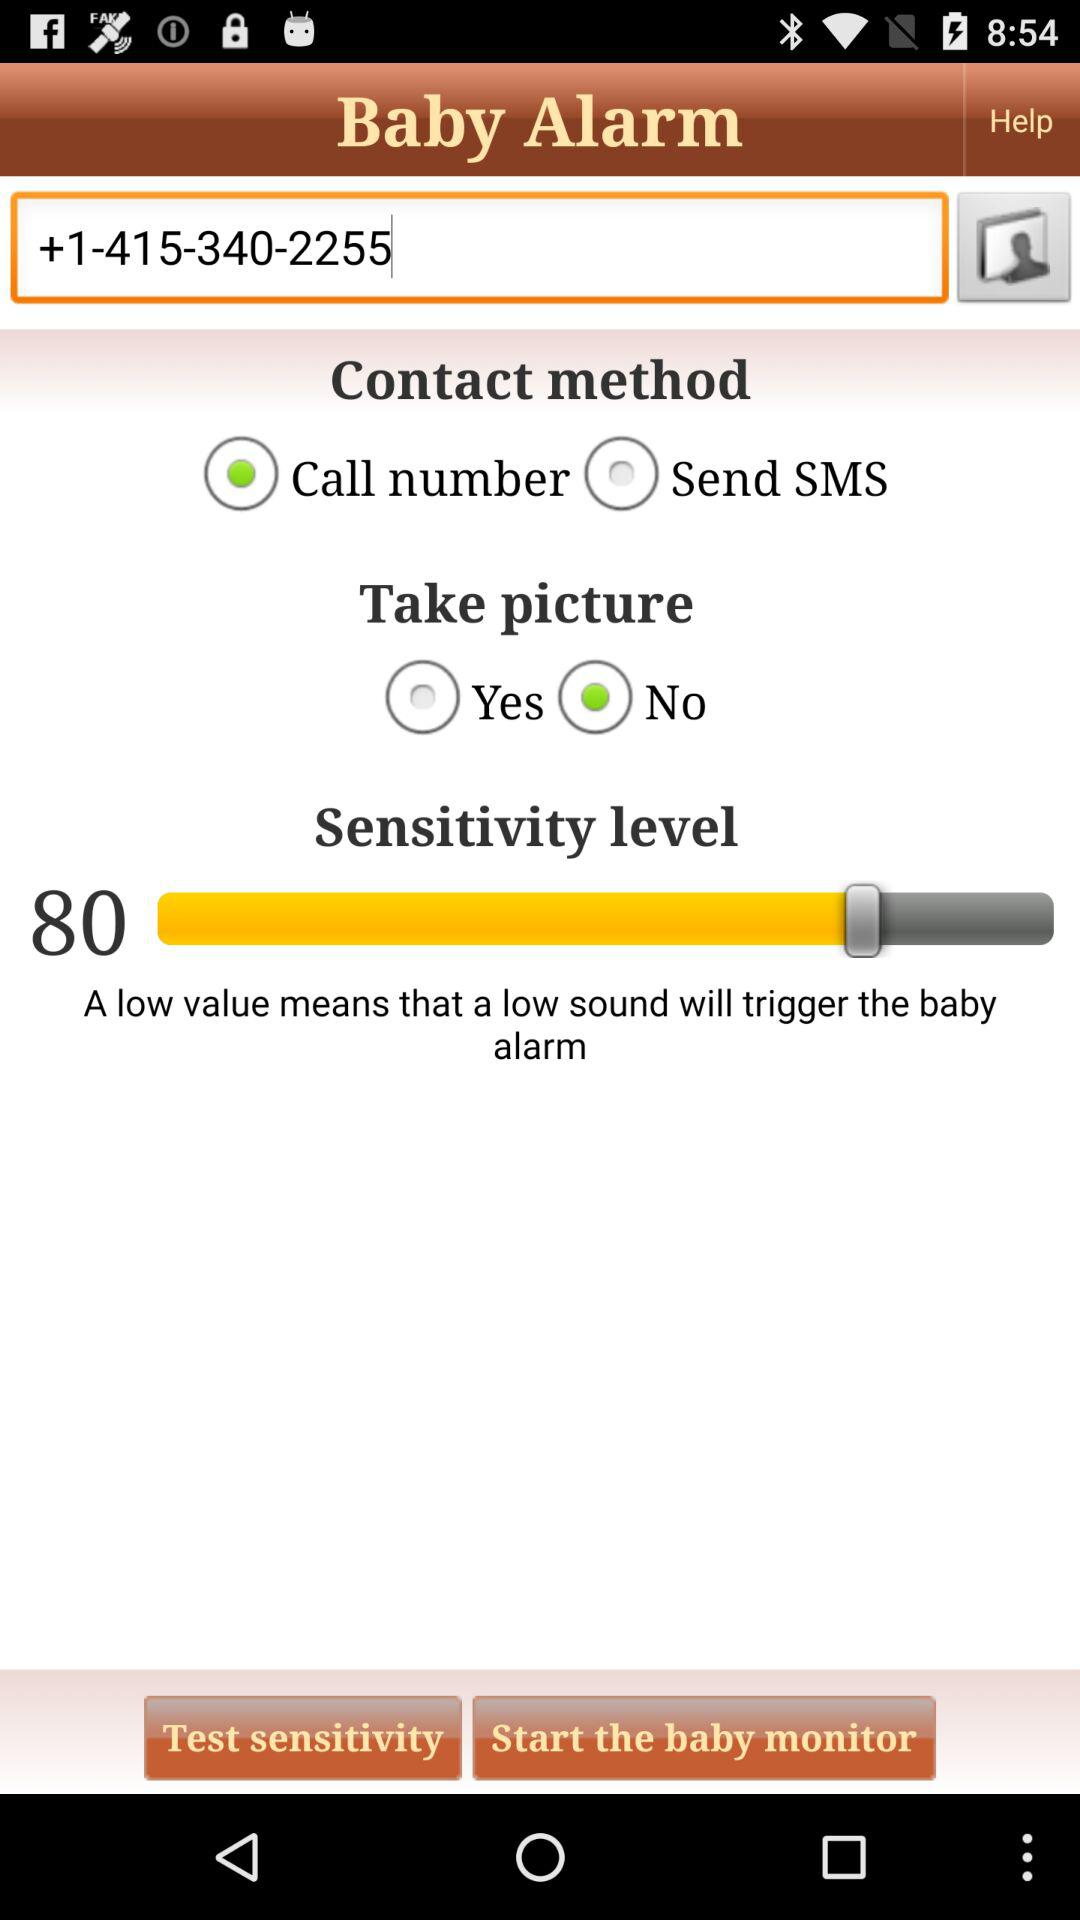Which option is "Call number" selected for? "Call number" is selected for "Contact method". 